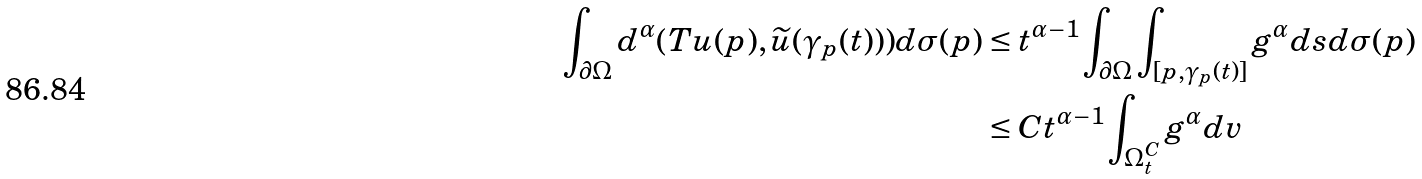<formula> <loc_0><loc_0><loc_500><loc_500>\int _ { \partial \Omega } d ^ { \alpha } ( T u ( p ) , \widetilde { u } ( \gamma _ { p } ( t ) ) ) d \sigma ( p ) & \leq t ^ { \alpha - 1 } \int _ { \partial \Omega } \int _ { [ p , \gamma _ { p } ( t ) ] } g ^ { \alpha } d s d \sigma ( p ) \\ & \leq C t ^ { \alpha - 1 } \int _ { \Omega _ { t } ^ { C } } g ^ { \alpha } d v</formula> 